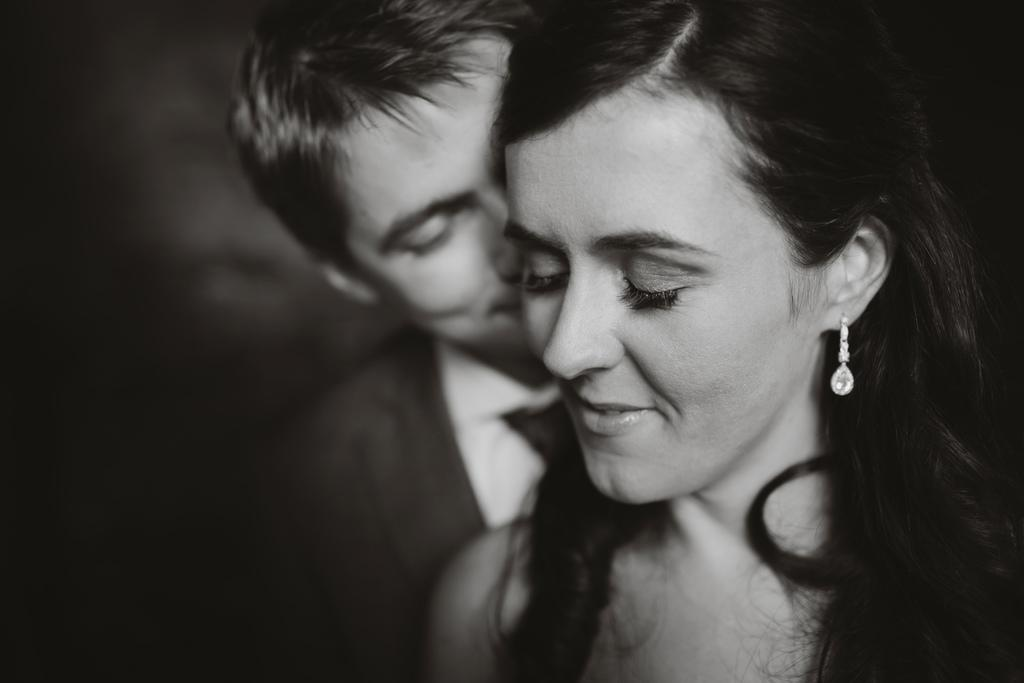How many people are in the image? There are two people in the image, a girl and a boy. Where are the girl and the boy located in the image? Both the girl and the boy are in the center of the image. What type of bean is the girl holding in the image? There is no bean present in the image; the girl and the boy are the main subjects. 